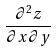Convert formula to latex. <formula><loc_0><loc_0><loc_500><loc_500>\frac { \partial ^ { 2 } z } { \partial x \partial y }</formula> 